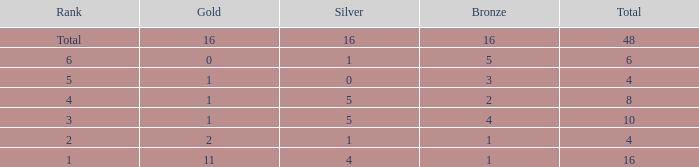How many total gold are less than 4? 0.0. 